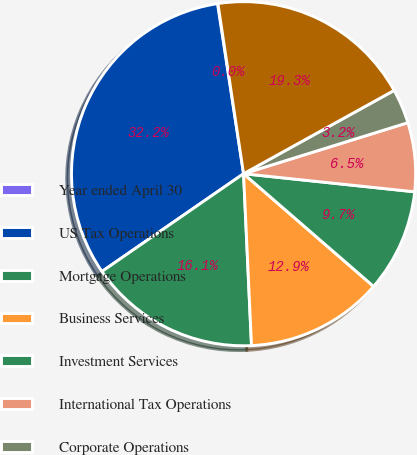<chart> <loc_0><loc_0><loc_500><loc_500><pie_chart><fcel>Year ended April 30<fcel>US Tax Operations<fcel>Mortgage Operations<fcel>Business Services<fcel>Investment Services<fcel>International Tax Operations<fcel>Corporate Operations<fcel>Pretax income<nl><fcel>0.04%<fcel>32.2%<fcel>16.12%<fcel>12.9%<fcel>9.69%<fcel>6.47%<fcel>3.25%<fcel>19.34%<nl></chart> 